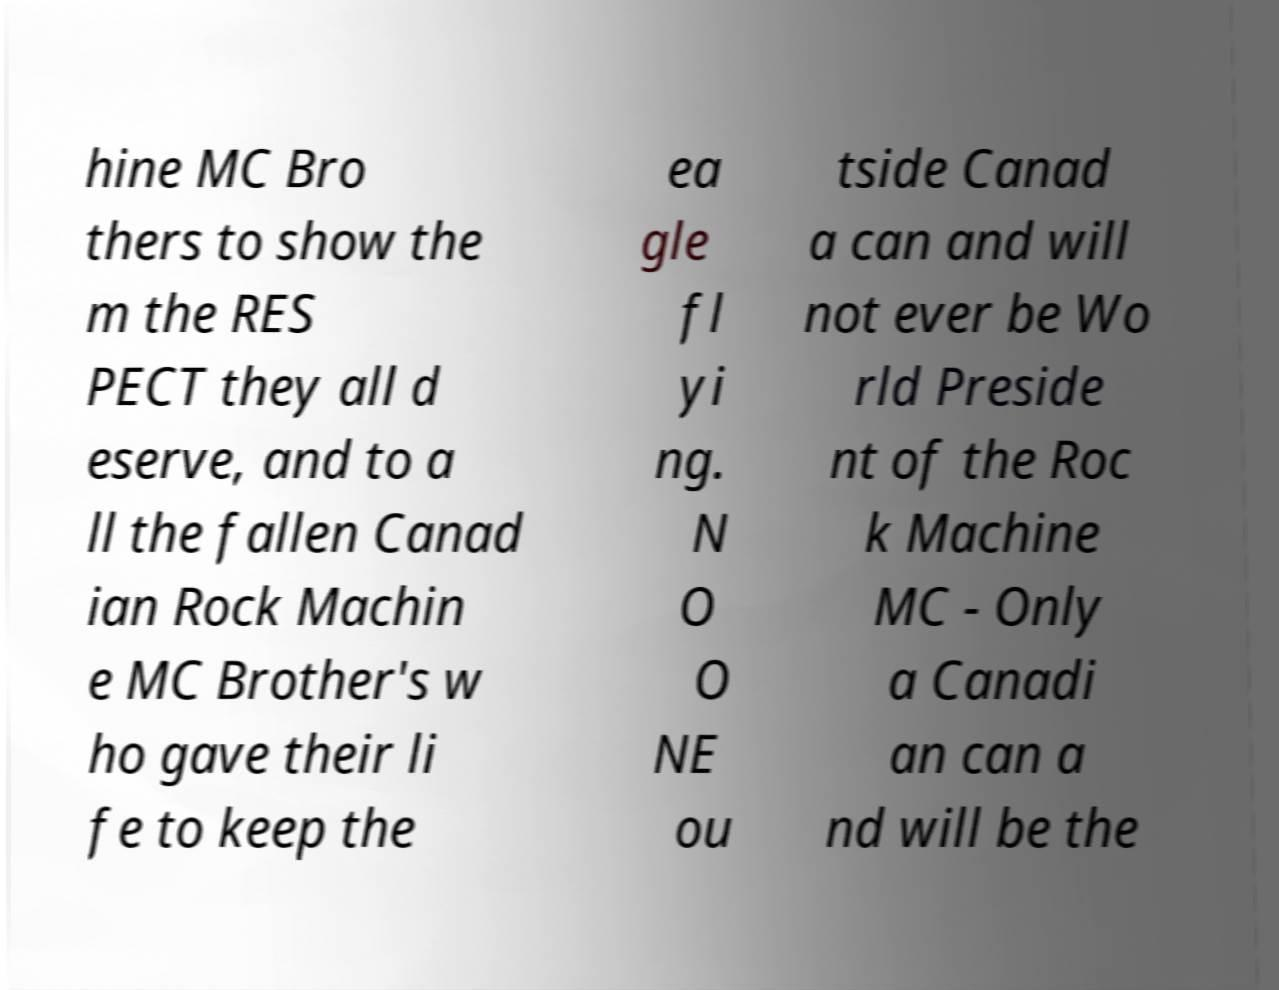There's text embedded in this image that I need extracted. Can you transcribe it verbatim? hine MC Bro thers to show the m the RES PECT they all d eserve, and to a ll the fallen Canad ian Rock Machin e MC Brother's w ho gave their li fe to keep the ea gle fl yi ng. N O O NE ou tside Canad a can and will not ever be Wo rld Preside nt of the Roc k Machine MC - Only a Canadi an can a nd will be the 